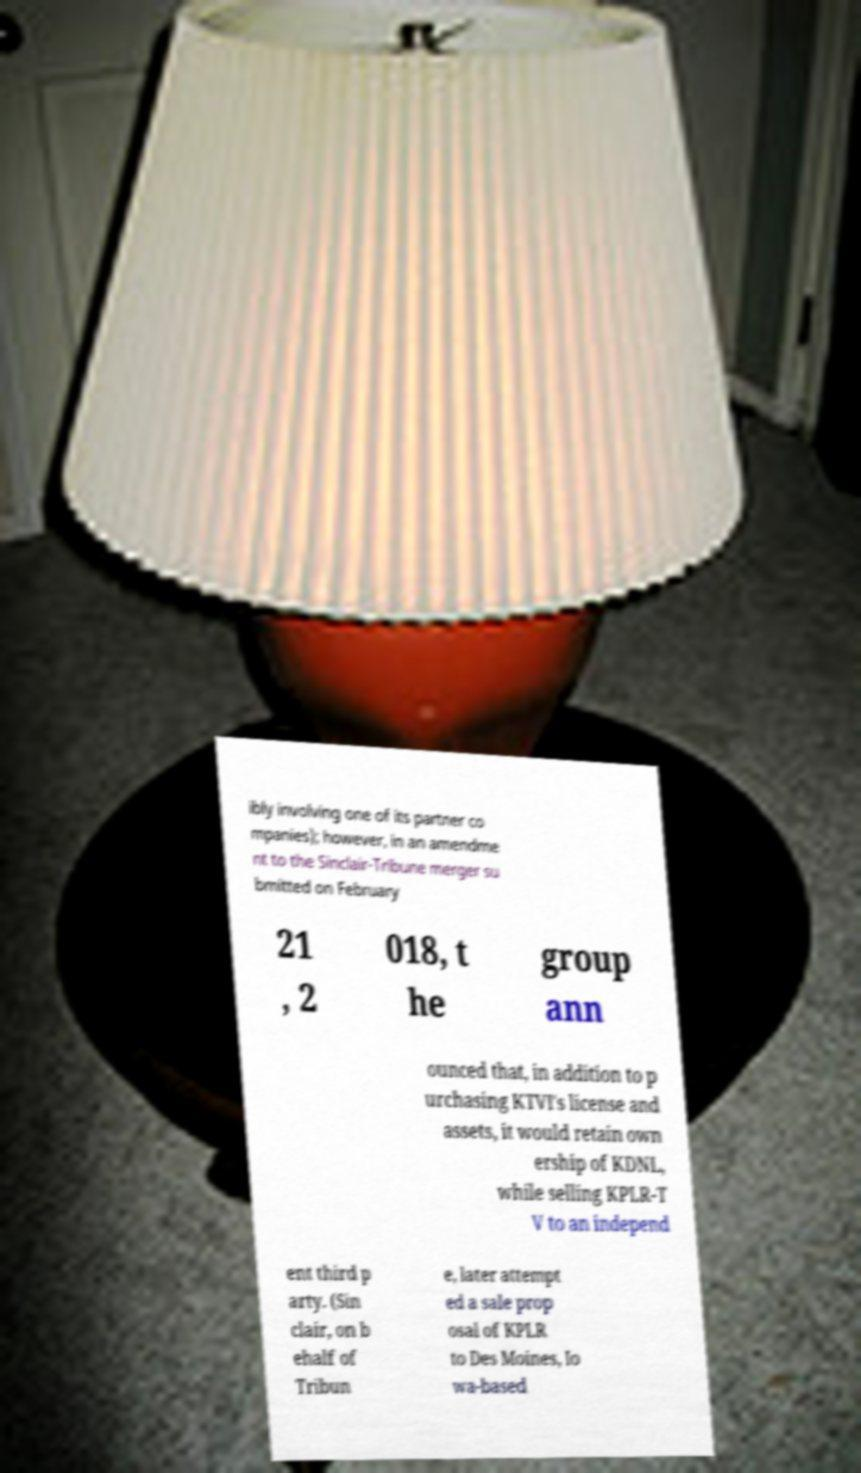Can you accurately transcribe the text from the provided image for me? ibly involving one of its partner co mpanies); however, in an amendme nt to the Sinclair-Tribune merger su bmitted on February 21 , 2 018, t he group ann ounced that, in addition to p urchasing KTVI's license and assets, it would retain own ership of KDNL, while selling KPLR-T V to an independ ent third p arty. (Sin clair, on b ehalf of Tribun e, later attempt ed a sale prop osal of KPLR to Des Moines, Io wa-based 